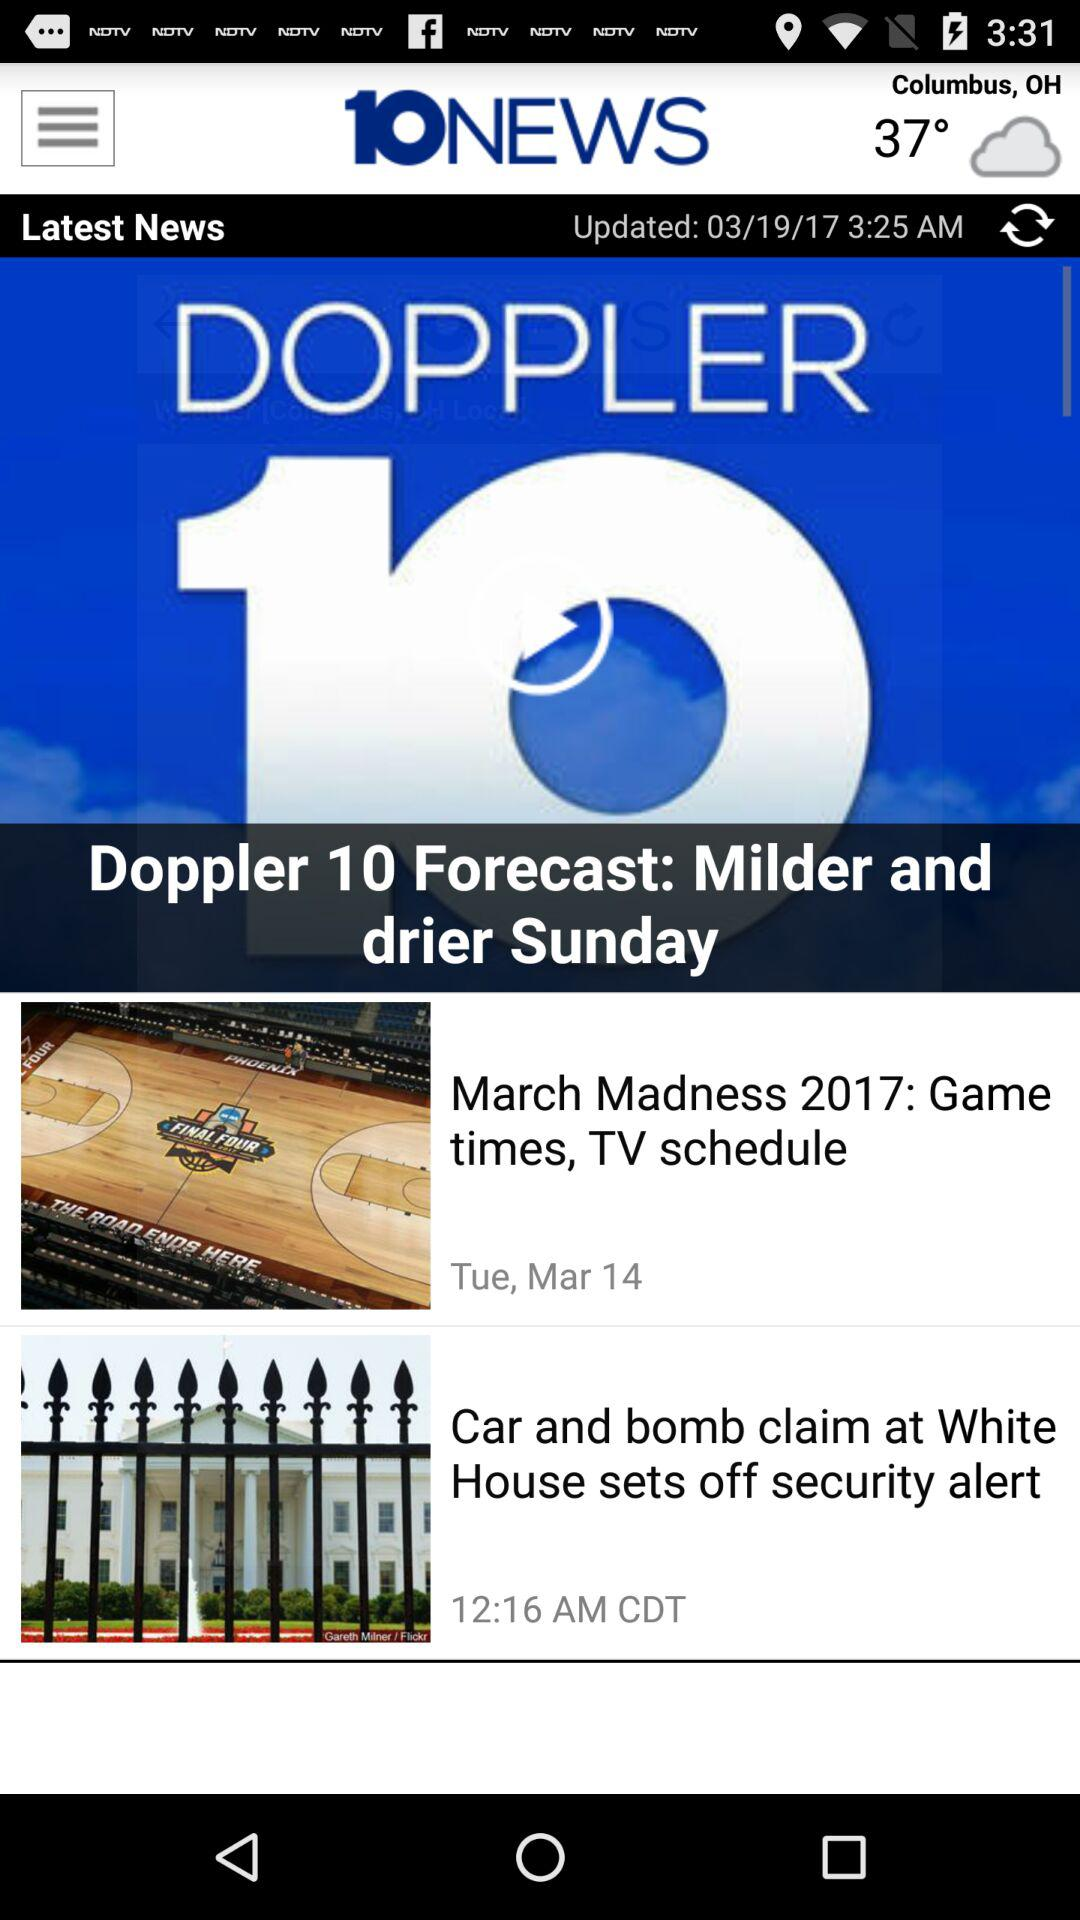Which article was updated at 12:16 am?
Answer the question using a single word or phrase. The article, which was updated at 12:16 a.m., is titled "Car and bomb claim at White House raises security concerns." 